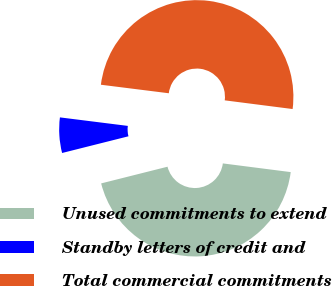Convert chart to OTSL. <chart><loc_0><loc_0><loc_500><loc_500><pie_chart><fcel>Unused commitments to extend<fcel>Standby letters of credit and<fcel>Total commercial commitments<nl><fcel>44.05%<fcel>5.91%<fcel>50.04%<nl></chart> 